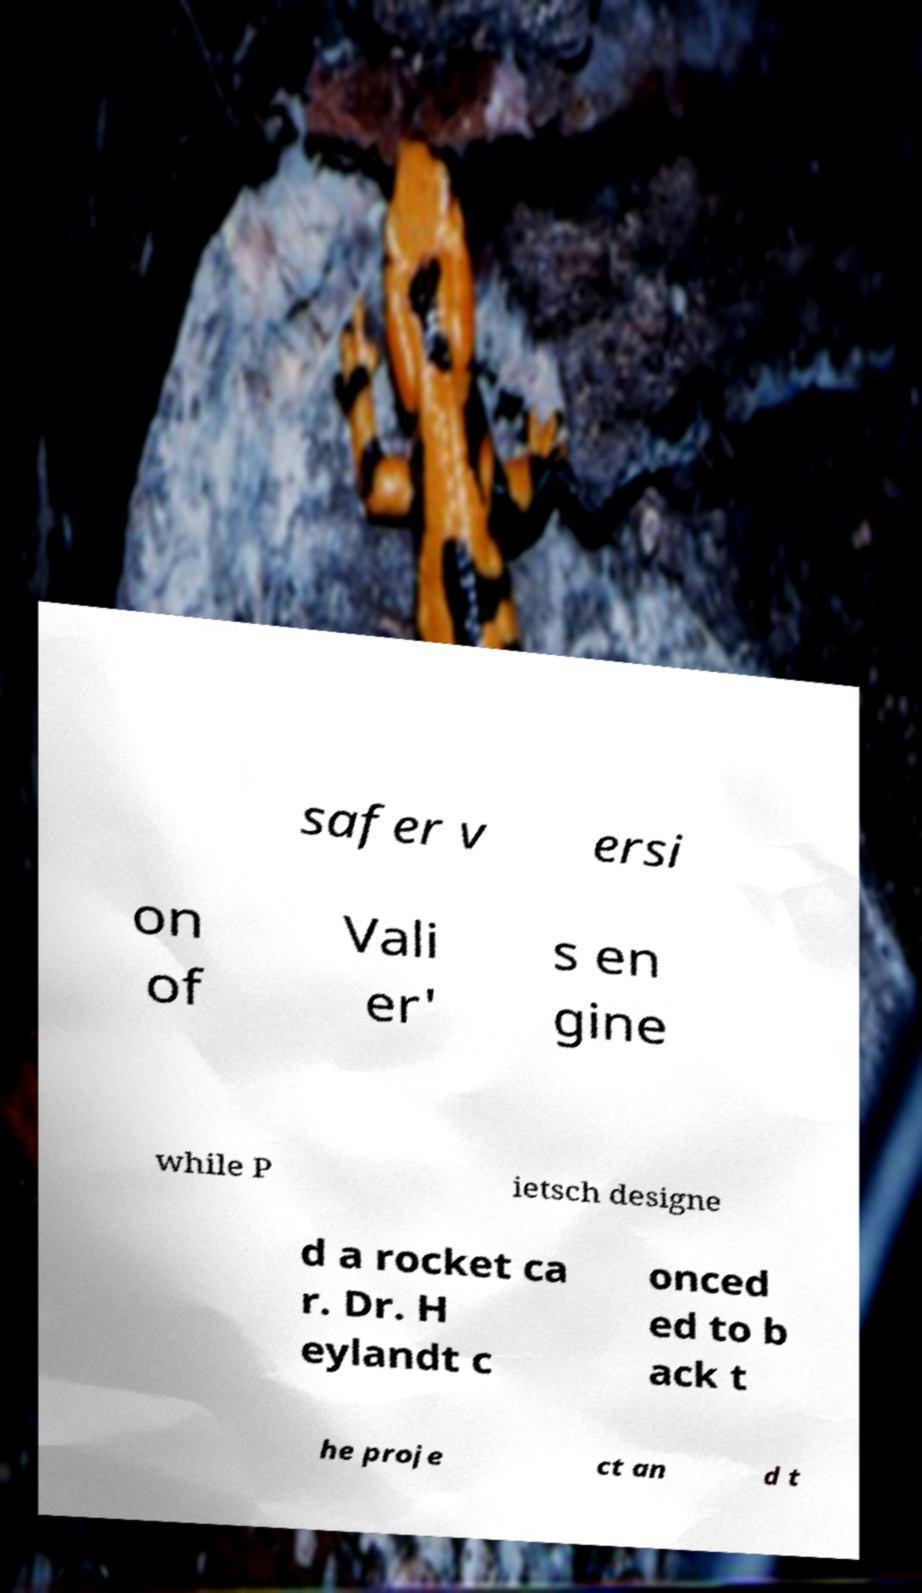For documentation purposes, I need the text within this image transcribed. Could you provide that? safer v ersi on of Vali er' s en gine while P ietsch designe d a rocket ca r. Dr. H eylandt c onced ed to b ack t he proje ct an d t 